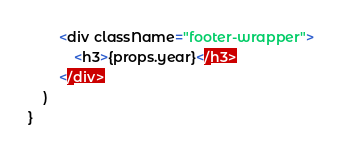Convert code to text. <code><loc_0><loc_0><loc_500><loc_500><_JavaScript_>        <div className="footer-wrapper">
            <h3>{props.year}</h3>
        </div>
    )
}</code> 